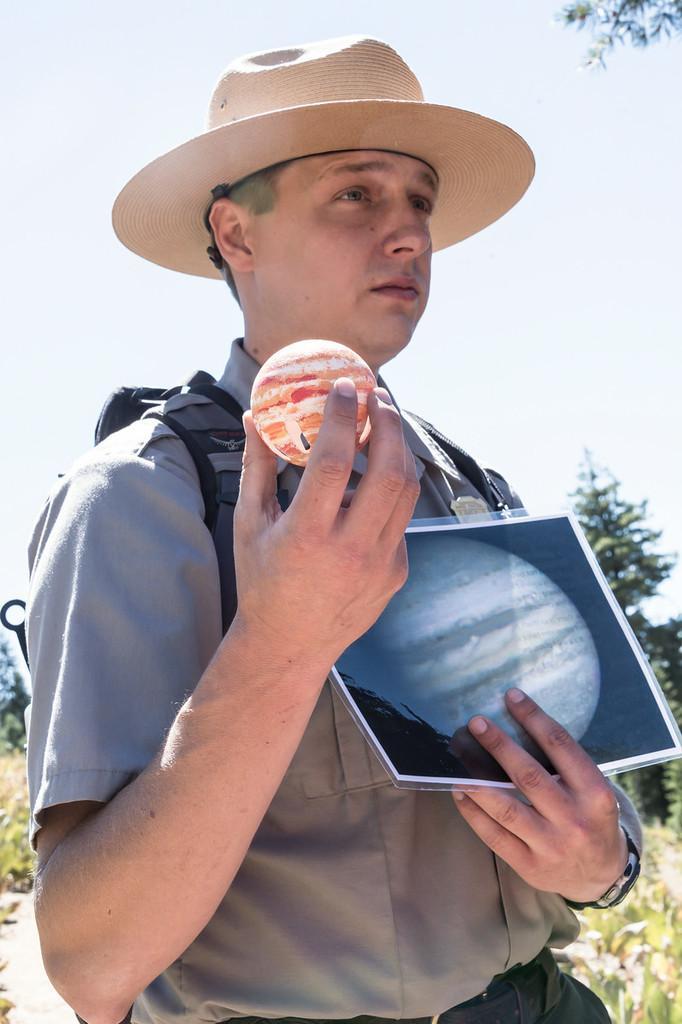Could you give a brief overview of what you see in this image? Here I can see a man wearing shirt, bag, holding a ball and a paper in the hands and facing towards the right side. I can see a cap on his head. In the background, I can see the plants and trees. On the top of the image I can see the sky. 